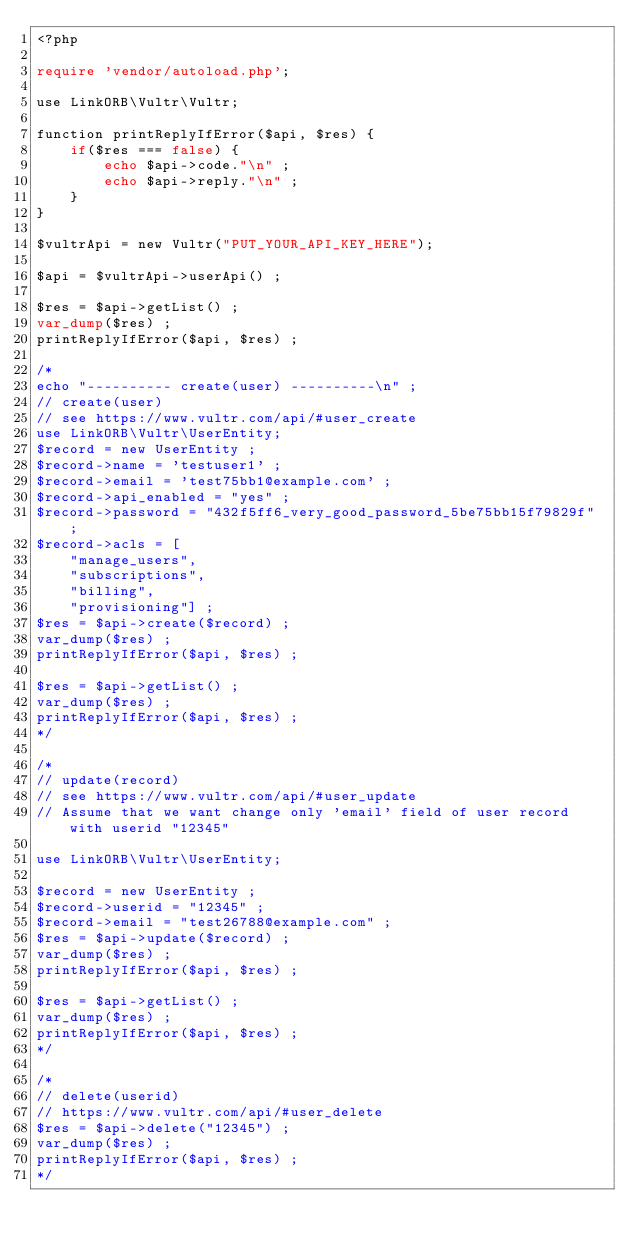<code> <loc_0><loc_0><loc_500><loc_500><_PHP_><?php

require 'vendor/autoload.php';

use LinkORB\Vultr\Vultr;

function printReplyIfError($api, $res) {
    if($res === false) {
        echo $api->code."\n" ;
        echo $api->reply."\n" ;
    }
}

$vultrApi = new Vultr("PUT_YOUR_API_KEY_HERE");

$api = $vultrApi->userApi() ;

$res = $api->getList() ;
var_dump($res) ;
printReplyIfError($api, $res) ;

/*
echo "---------- create(user) ----------\n" ;
// create(user)
// see https://www.vultr.com/api/#user_create
use LinkORB\Vultr\UserEntity;
$record = new UserEntity ;
$record->name = 'testuser1' ;
$record->email = 'test75bb1@example.com' ;
$record->api_enabled = "yes" ;
$record->password = "432f5ff6_very_good_password_5be75bb15f79829f" ;
$record->acls = [         
    "manage_users",
    "subscriptions",
    "billing",
    "provisioning"] ;
$res = $api->create($record) ;
var_dump($res) ;
printReplyIfError($api, $res) ;

$res = $api->getList() ;
var_dump($res) ;
printReplyIfError($api, $res) ;
*/

/*
// update(record)
// see https://www.vultr.com/api/#user_update
// Assume that we want change only 'email' field of user record with userid "12345"

use LinkORB\Vultr\UserEntity;

$record = new UserEntity ;
$record->userid = "12345" ;
$record->email = "test26788@example.com" ;
$res = $api->update($record) ;
var_dump($res) ;
printReplyIfError($api, $res) ;

$res = $api->getList() ;
var_dump($res) ;
printReplyIfError($api, $res) ;
*/

/*
// delete(userid)
// https://www.vultr.com/api/#user_delete
$res = $api->delete("12345") ;
var_dump($res) ;
printReplyIfError($api, $res) ;
*/
</code> 